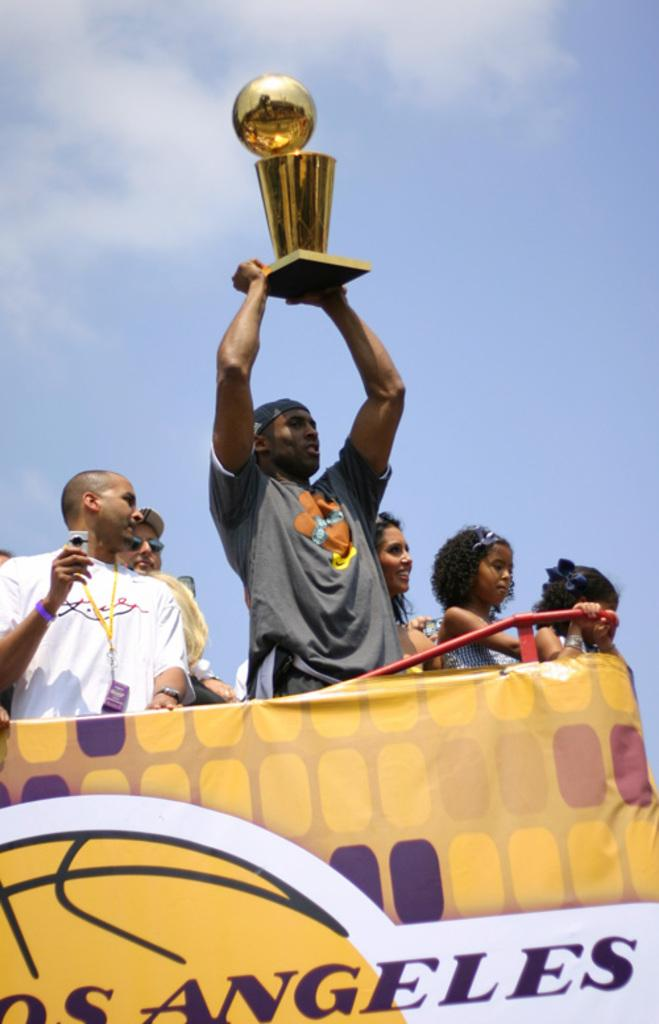What is hanging or displayed in the image? There is a banner in the image. Can you describe the people in the image? There is a group of people in the image. What is visible at the top of the image? The sky is visible at the top of the image. How many faces can be seen on the banner in the image? There is no face present on the banner in the image. What is the fifth item in the image? The provided facts do not mention five items in the image, so it is impossible to answer this question. 